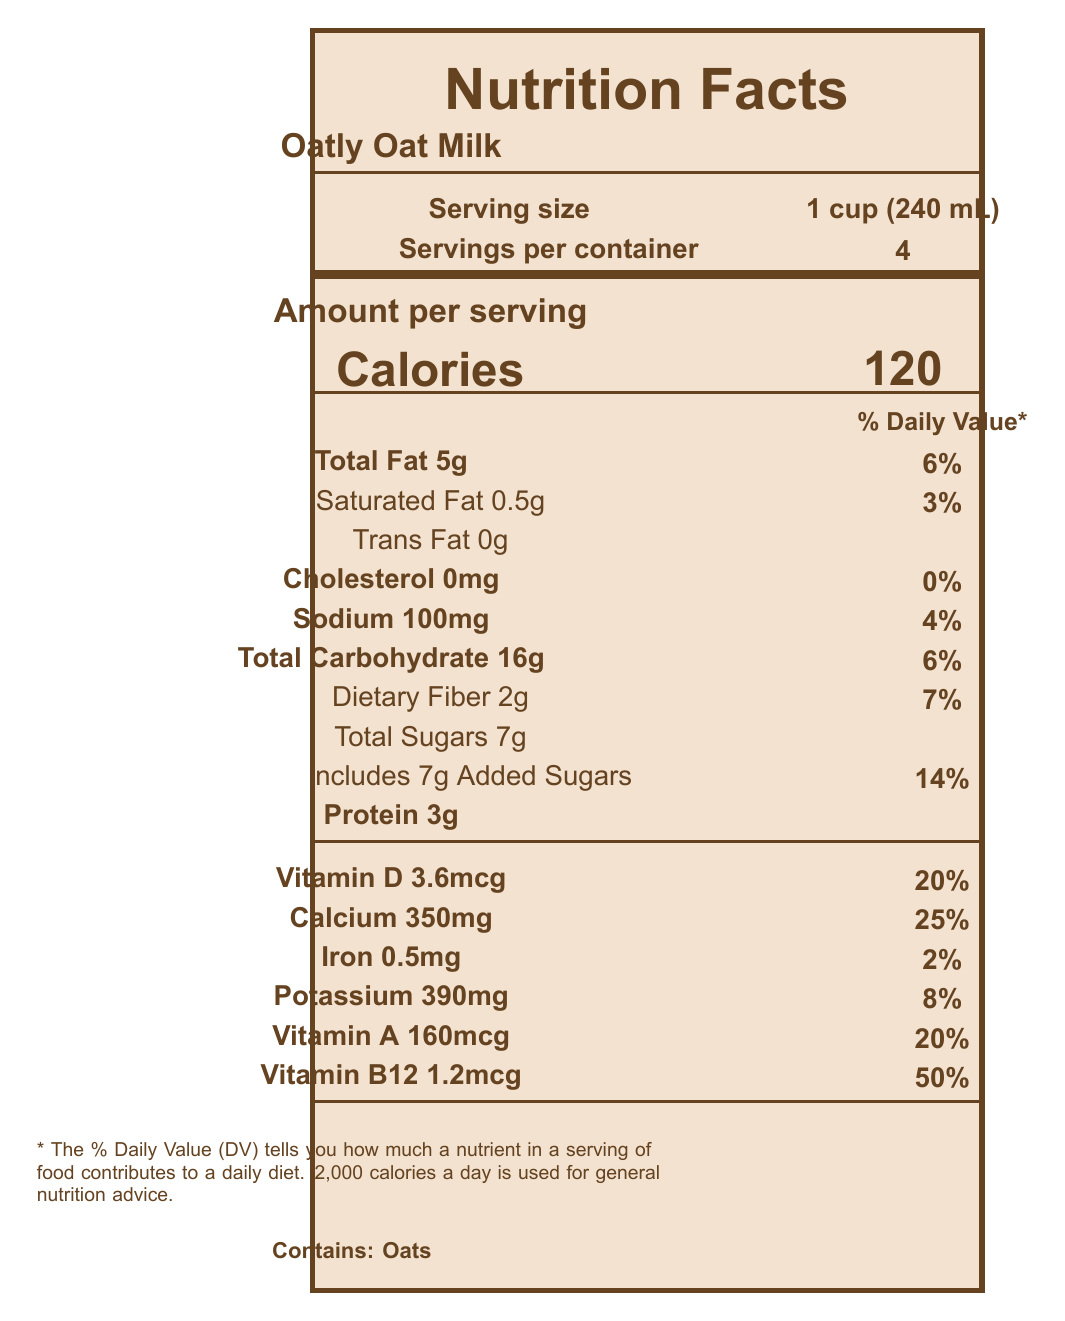What is the serving size of Oatly Oat Milk? The serving size is listed under the heading "Serving size" as "1 cup (240 mL)" in the document.
Answer: 1 cup (240 mL) How many calories are in one serving of Oatly Oat Milk? The calories per serving are stated as "Calories 120" under the heading "Amount per serving".
Answer: 120 How much total fat is in one serving of Oatly Oat Milk? The total fat per serving is listed as "Total Fat 5g" under the heading "Amount per serving".
Answer: 5g What is the percentage daily value of Vitamin D in Oatly Oat Milk? The percentage daily value for Vitamin D is indicated as "Vitamin D 3.6mcg 20%" in the document.
Answer: 20% Does Oatly Oat Milk contain cholesterol? Under the line "Cholesterol", it states "0mg" with a daily value of "0%", indicating that it contains no cholesterol.
Answer: No Which of the following nutrients does Oatly Oat Milk contain more of compared to whole milk? A. Protein B. Calcium C. Saturated Fat D. Cholesterol Oatly Oat Milk contains 350mg of Calcium compared to 300mg in whole milk.
Answer: B How many grams of protein does Oatly Oat Milk contain per serving? A. 2g B. 3g C. 5g D. 8g The document states "Protein 3g" under the amount per serving section.
Answer: B What is the environmental impact of Oatly Oat Milk in terms of water usage compared to dairy milk? The document states that Oatly Oat Milk uses "80% less than dairy milk" in terms of water usage.
Answer: 80% less Is Oatly Oat Milk produced in a facility that processes milk? The allergen information mentions that it is "Produced in a facility that processes milk".
Answer: Yes Does Oatly Oat Milk contain any added sugars? The document lists "Includes 7g Added Sugars" under the total carbohydrates section.
Answer: Yes Describe the overall nutritional benefits and environmental impact of Oatly Oat Milk as presented in the document. The document outlines Oatly Oat Milk’s nutritional benefits such as lower calories, fat, cholesterol-free, and high in calcium. It is also fortified with vitamins A, D, and B12. Environmentally, it highlights using 80% less water, 79% less land, and 73% fewer carbon emissions than dairy milk.
Answer: Oatly Oat Milk is presented as a lower-calorie, lower-fat, and cholesterol-free alternative to whole milk. It is fortified with essential vitamins and minerals like calcium, Vitamin D, and B12. Environmentally, it is more sustainable, using significantly less water, land, and producing fewer carbon emissions compared to dairy milk. What is the land usage percentage reduction of Oatly Oat Milk compared to dairy milk? The document specifically states "land usage: 79% less than dairy milk" in the environmental impact section.
Answer: 79% less What is the protein content difference between Oatly Oat Milk and whole milk? Oatly Oat Milk contains 3g of protein per serving, whereas whole milk contains 8g, making the difference 5g less in Oatly Oat Milk.
Answer: 5g less Can we determine the exact amount of sugar in whole milk from the document? The document does not provide information on the sugar content of whole milk.
Answer: Cannot be determined 